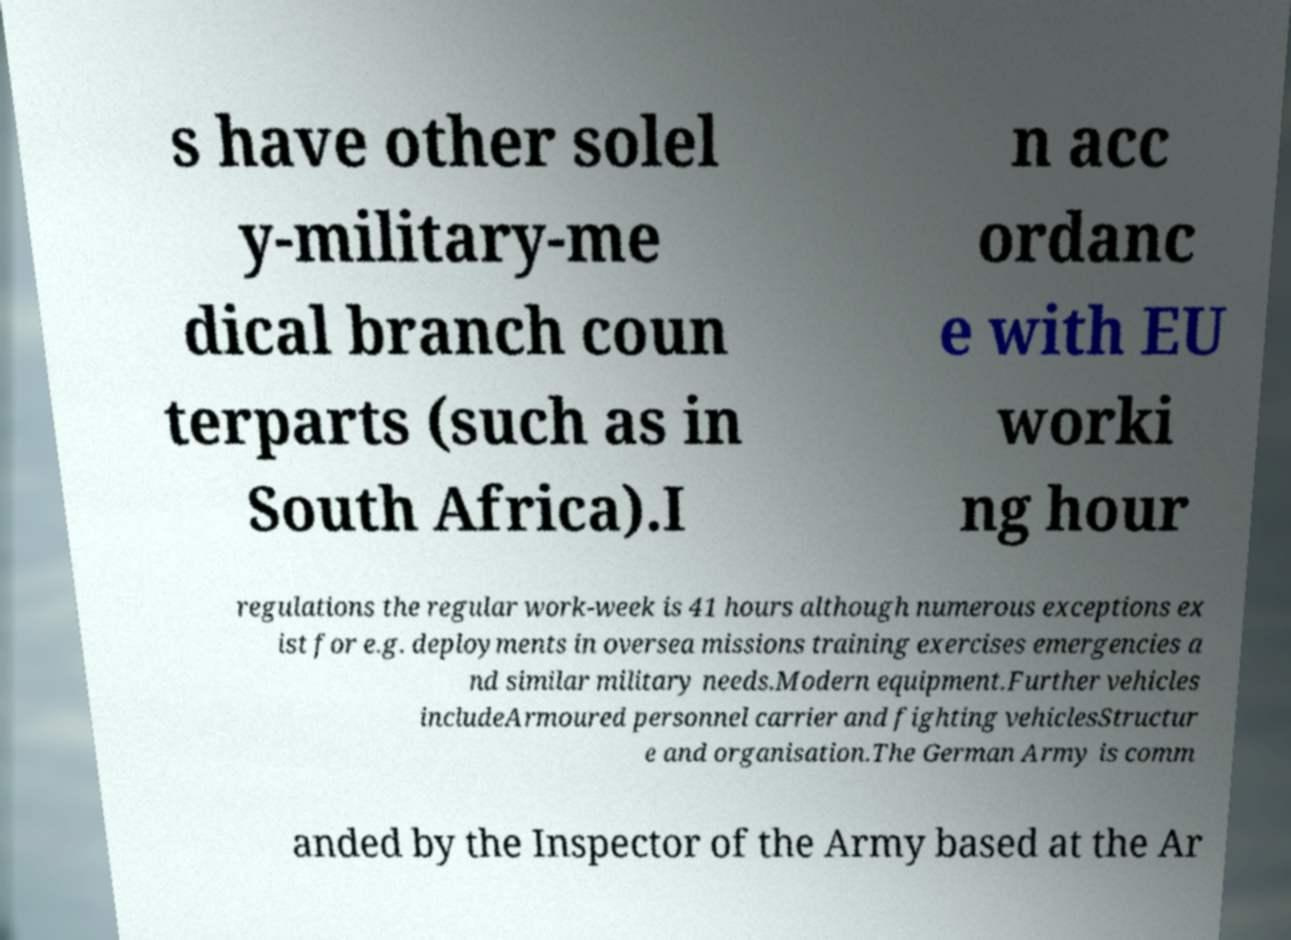Please read and relay the text visible in this image. What does it say? s have other solel y-military-me dical branch coun terparts (such as in South Africa).I n acc ordanc e with EU worki ng hour regulations the regular work-week is 41 hours although numerous exceptions ex ist for e.g. deployments in oversea missions training exercises emergencies a nd similar military needs.Modern equipment.Further vehicles includeArmoured personnel carrier and fighting vehiclesStructur e and organisation.The German Army is comm anded by the Inspector of the Army based at the Ar 